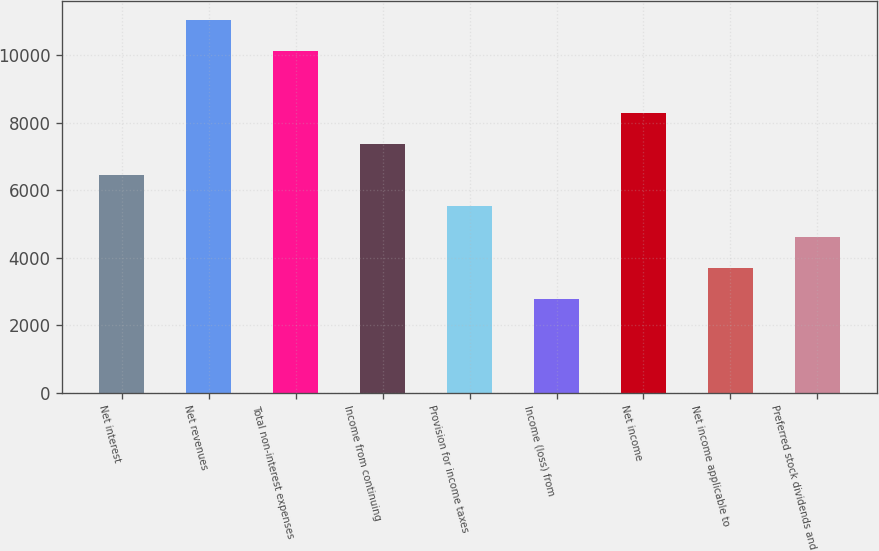<chart> <loc_0><loc_0><loc_500><loc_500><bar_chart><fcel>Net interest<fcel>Net revenues<fcel>Total non-interest expenses<fcel>Income from continuing<fcel>Provision for income taxes<fcel>Income (loss) from<fcel>Net income<fcel>Net income applicable to<fcel>Preferred stock dividends and<nl><fcel>6437.99<fcel>11036.3<fcel>10116.7<fcel>7357.66<fcel>5518.32<fcel>2759.28<fcel>8277.33<fcel>3678.96<fcel>4598.64<nl></chart> 